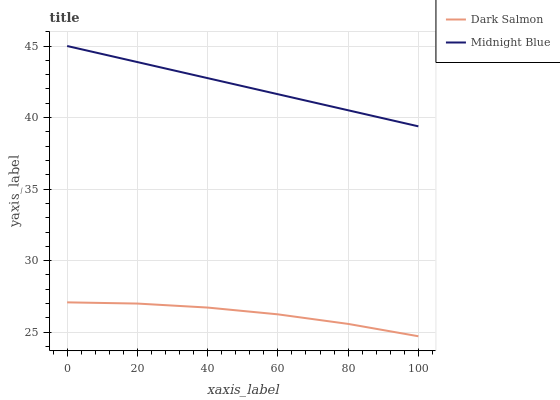Does Dark Salmon have the minimum area under the curve?
Answer yes or no. Yes. Does Midnight Blue have the maximum area under the curve?
Answer yes or no. Yes. Does Midnight Blue have the minimum area under the curve?
Answer yes or no. No. Is Midnight Blue the smoothest?
Answer yes or no. Yes. Is Dark Salmon the roughest?
Answer yes or no. Yes. Is Midnight Blue the roughest?
Answer yes or no. No. Does Dark Salmon have the lowest value?
Answer yes or no. Yes. Does Midnight Blue have the lowest value?
Answer yes or no. No. Does Midnight Blue have the highest value?
Answer yes or no. Yes. Is Dark Salmon less than Midnight Blue?
Answer yes or no. Yes. Is Midnight Blue greater than Dark Salmon?
Answer yes or no. Yes. Does Dark Salmon intersect Midnight Blue?
Answer yes or no. No. 